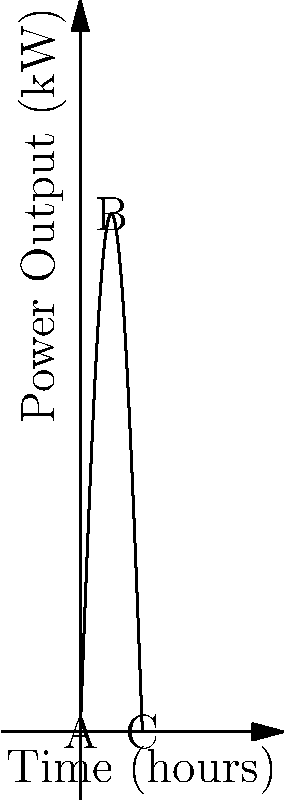A solar panel array's power output over a 12-hour period is modeled by the function $P(t) = 100\sin(\frac{\pi t}{12})$, where $P$ is the power output in kilowatts and $t$ is the time in hours. At what time during this period is the rate of change of power output maximized, and what is this maximum rate? To solve this problem, we'll follow these steps:

1) The rate of change of power output is given by the derivative of $P(t)$. Let's find $P'(t)$:

   $P'(t) = 100 \cdot \frac{\pi}{12} \cos(\frac{\pi t}{12})$

2) To find the maximum rate of change, we need to find where the second derivative $P''(t)$ equals zero:

   $P''(t) = 100 \cdot (\frac{\pi}{12})^2 \cdot (-\sin(\frac{\pi t}{12}))$

3) Setting $P''(t) = 0$:

   $-100 \cdot (\frac{\pi}{12})^2 \cdot \sin(\frac{\pi t}{12}) = 0$

4) This equation is satisfied when $\sin(\frac{\pi t}{12}) = 0$, which occurs when $\frac{\pi t}{12} = 0$ or $\pi$.

5) Solving for $t$:
   
   $t = 0$ or $t = 12$

6) To determine which of these gives the maximum (rather than minimum) rate of change, we can check the sign of $P'''(t)$ at these points:

   $P'''(t) = -100 \cdot (\frac{\pi}{12})^3 \cdot \cos(\frac{\pi t}{12})$

   At $t = 0$: $P'''(0) < 0$, indicating a maximum
   At $t = 12$: $P'''(12) > 0$, indicating a minimum

7) Therefore, the rate of change is maximized at $t = 0$.

8) The maximum rate of change is:

   $P'(0) = 100 \cdot \frac{\pi}{12} \cos(0) = \frac{25\pi}{3}$ kW/hour
Answer: Time: 0 hours; Maximum rate: $\frac{25\pi}{3}$ kW/hour 